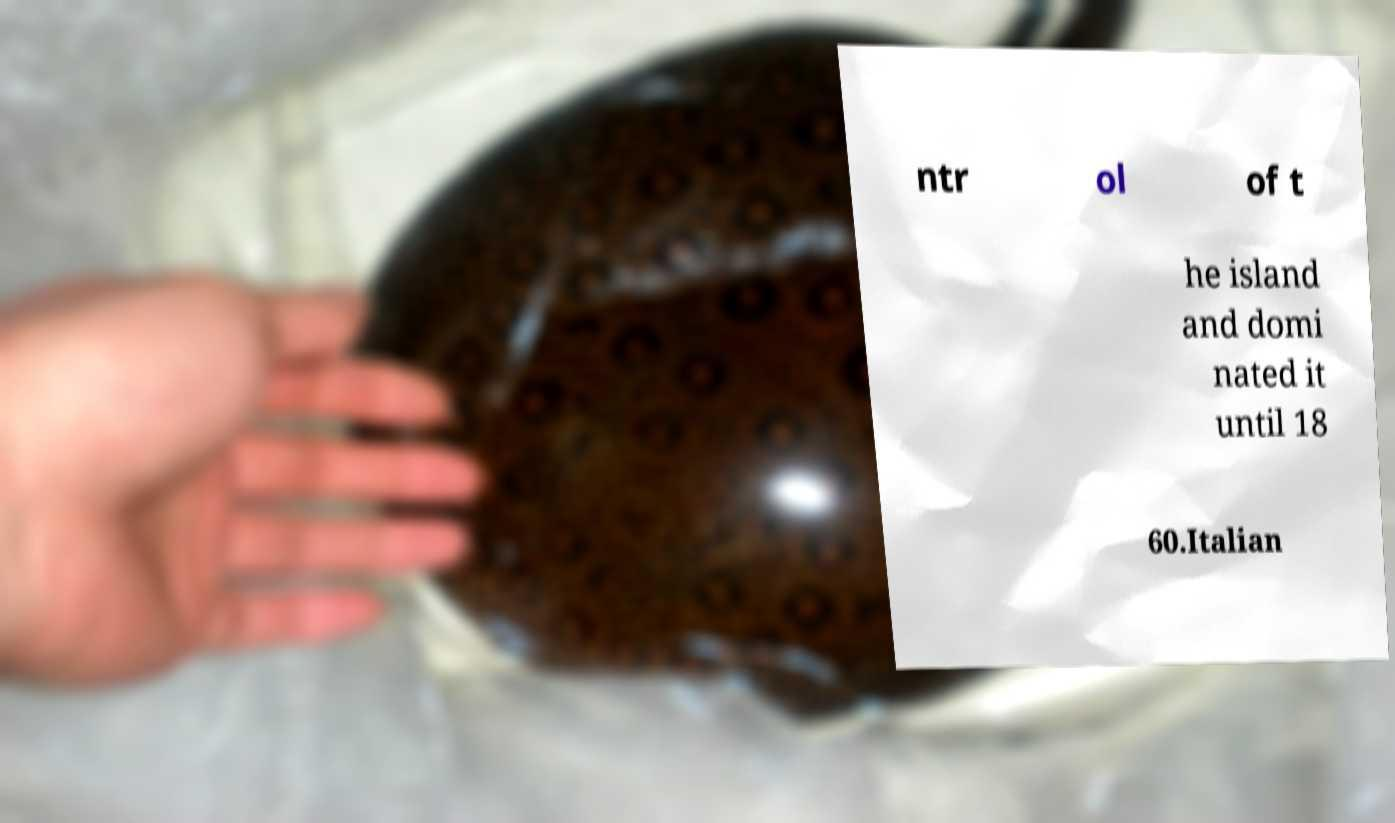Please read and relay the text visible in this image. What does it say? ntr ol of t he island and domi nated it until 18 60.Italian 